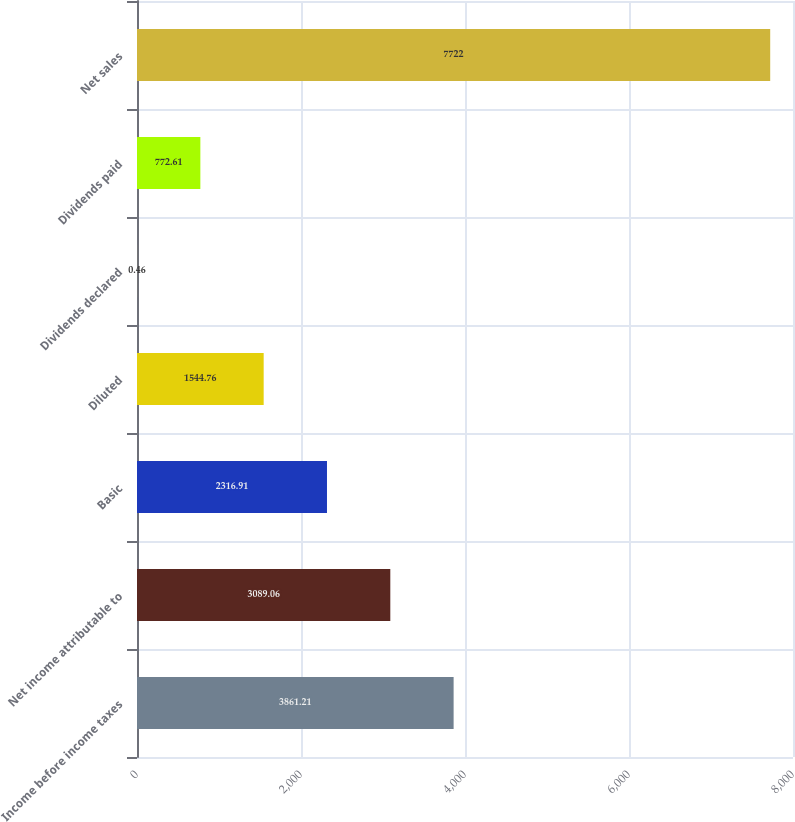Convert chart. <chart><loc_0><loc_0><loc_500><loc_500><bar_chart><fcel>Income before income taxes<fcel>Net income attributable to<fcel>Basic<fcel>Diluted<fcel>Dividends declared<fcel>Dividends paid<fcel>Net sales<nl><fcel>3861.21<fcel>3089.06<fcel>2316.91<fcel>1544.76<fcel>0.46<fcel>772.61<fcel>7722<nl></chart> 